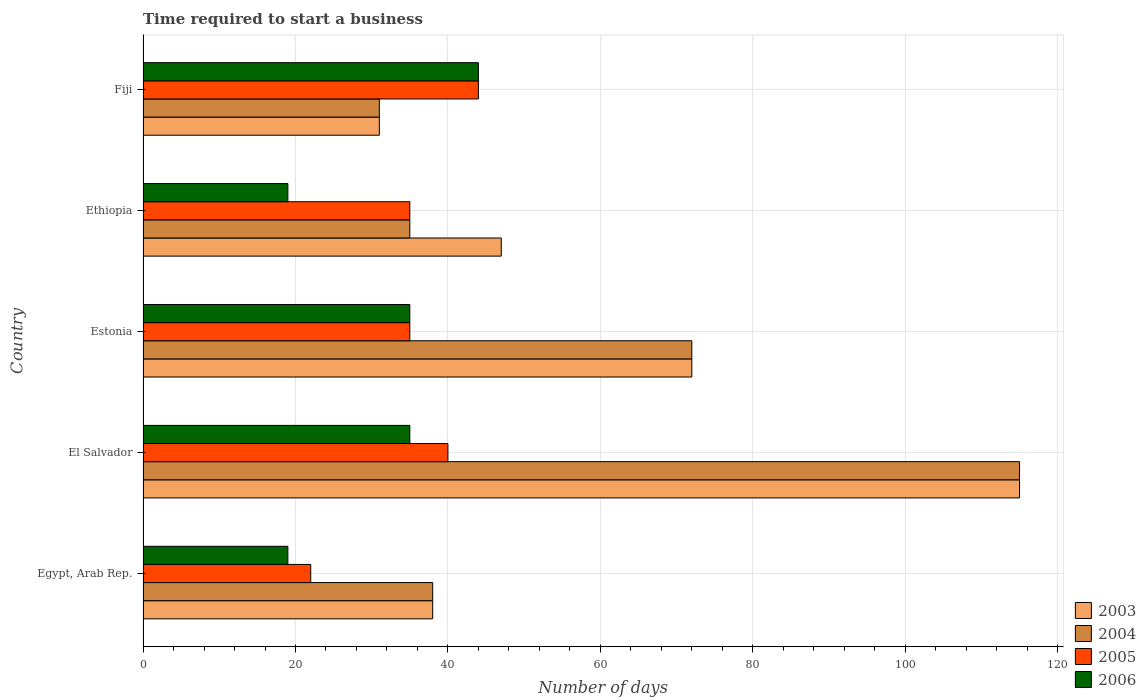How many different coloured bars are there?
Provide a short and direct response. 4. Are the number of bars on each tick of the Y-axis equal?
Your answer should be very brief. Yes. How many bars are there on the 3rd tick from the top?
Give a very brief answer. 4. How many bars are there on the 4th tick from the bottom?
Offer a very short reply. 4. What is the label of the 3rd group of bars from the top?
Your answer should be very brief. Estonia. What is the number of days required to start a business in 2003 in Ethiopia?
Offer a very short reply. 47. Across all countries, what is the maximum number of days required to start a business in 2004?
Offer a very short reply. 115. In which country was the number of days required to start a business in 2006 maximum?
Offer a very short reply. Fiji. In which country was the number of days required to start a business in 2005 minimum?
Your answer should be compact. Egypt, Arab Rep. What is the total number of days required to start a business in 2004 in the graph?
Offer a terse response. 291. What is the difference between the number of days required to start a business in 2003 in El Salvador and that in Estonia?
Give a very brief answer. 43. What is the difference between the number of days required to start a business in 2005 in Fiji and the number of days required to start a business in 2004 in Ethiopia?
Give a very brief answer. 9. What is the average number of days required to start a business in 2005 per country?
Offer a terse response. 35.2. In how many countries, is the number of days required to start a business in 2003 greater than 20 days?
Make the answer very short. 5. What is the ratio of the number of days required to start a business in 2003 in Egypt, Arab Rep. to that in Estonia?
Ensure brevity in your answer.  0.53. Is the difference between the number of days required to start a business in 2003 in El Salvador and Fiji greater than the difference between the number of days required to start a business in 2004 in El Salvador and Fiji?
Offer a terse response. No. What is the difference between the highest and the lowest number of days required to start a business in 2003?
Offer a very short reply. 84. Is it the case that in every country, the sum of the number of days required to start a business in 2005 and number of days required to start a business in 2006 is greater than the number of days required to start a business in 2004?
Provide a short and direct response. No. Are all the bars in the graph horizontal?
Keep it short and to the point. Yes. What is the difference between two consecutive major ticks on the X-axis?
Your response must be concise. 20. Are the values on the major ticks of X-axis written in scientific E-notation?
Ensure brevity in your answer.  No. Where does the legend appear in the graph?
Your answer should be compact. Bottom right. How many legend labels are there?
Give a very brief answer. 4. What is the title of the graph?
Provide a short and direct response. Time required to start a business. Does "1980" appear as one of the legend labels in the graph?
Keep it short and to the point. No. What is the label or title of the X-axis?
Give a very brief answer. Number of days. What is the label or title of the Y-axis?
Give a very brief answer. Country. What is the Number of days of 2003 in Egypt, Arab Rep.?
Provide a succinct answer. 38. What is the Number of days of 2004 in Egypt, Arab Rep.?
Provide a short and direct response. 38. What is the Number of days in 2005 in Egypt, Arab Rep.?
Your answer should be compact. 22. What is the Number of days of 2003 in El Salvador?
Provide a succinct answer. 115. What is the Number of days in 2004 in El Salvador?
Give a very brief answer. 115. What is the Number of days of 2005 in El Salvador?
Your answer should be very brief. 40. What is the Number of days of 2006 in El Salvador?
Your answer should be compact. 35. What is the Number of days of 2004 in Estonia?
Offer a very short reply. 72. What is the Number of days of 2006 in Estonia?
Your response must be concise. 35. What is the Number of days of 2004 in Ethiopia?
Your answer should be compact. 35. What is the Number of days in 2003 in Fiji?
Make the answer very short. 31. Across all countries, what is the maximum Number of days of 2003?
Offer a terse response. 115. Across all countries, what is the maximum Number of days of 2004?
Your answer should be very brief. 115. Across all countries, what is the maximum Number of days in 2005?
Your response must be concise. 44. Across all countries, what is the minimum Number of days of 2003?
Ensure brevity in your answer.  31. Across all countries, what is the minimum Number of days in 2006?
Your answer should be very brief. 19. What is the total Number of days of 2003 in the graph?
Provide a short and direct response. 303. What is the total Number of days in 2004 in the graph?
Provide a short and direct response. 291. What is the total Number of days in 2005 in the graph?
Offer a very short reply. 176. What is the total Number of days of 2006 in the graph?
Your answer should be very brief. 152. What is the difference between the Number of days of 2003 in Egypt, Arab Rep. and that in El Salvador?
Ensure brevity in your answer.  -77. What is the difference between the Number of days in 2004 in Egypt, Arab Rep. and that in El Salvador?
Ensure brevity in your answer.  -77. What is the difference between the Number of days of 2005 in Egypt, Arab Rep. and that in El Salvador?
Keep it short and to the point. -18. What is the difference between the Number of days in 2006 in Egypt, Arab Rep. and that in El Salvador?
Ensure brevity in your answer.  -16. What is the difference between the Number of days of 2003 in Egypt, Arab Rep. and that in Estonia?
Ensure brevity in your answer.  -34. What is the difference between the Number of days of 2004 in Egypt, Arab Rep. and that in Estonia?
Your answer should be compact. -34. What is the difference between the Number of days in 2006 in Egypt, Arab Rep. and that in Estonia?
Provide a succinct answer. -16. What is the difference between the Number of days of 2003 in Egypt, Arab Rep. and that in Ethiopia?
Your answer should be compact. -9. What is the difference between the Number of days in 2004 in Egypt, Arab Rep. and that in Ethiopia?
Offer a terse response. 3. What is the difference between the Number of days in 2005 in Egypt, Arab Rep. and that in Ethiopia?
Keep it short and to the point. -13. What is the difference between the Number of days of 2003 in Egypt, Arab Rep. and that in Fiji?
Your answer should be very brief. 7. What is the difference between the Number of days in 2006 in Egypt, Arab Rep. and that in Fiji?
Keep it short and to the point. -25. What is the difference between the Number of days in 2003 in El Salvador and that in Ethiopia?
Ensure brevity in your answer.  68. What is the difference between the Number of days in 2004 in El Salvador and that in Ethiopia?
Your answer should be compact. 80. What is the difference between the Number of days in 2005 in El Salvador and that in Fiji?
Your response must be concise. -4. What is the difference between the Number of days in 2003 in Estonia and that in Ethiopia?
Keep it short and to the point. 25. What is the difference between the Number of days of 2005 in Estonia and that in Ethiopia?
Your response must be concise. 0. What is the difference between the Number of days of 2005 in Estonia and that in Fiji?
Your answer should be very brief. -9. What is the difference between the Number of days in 2004 in Ethiopia and that in Fiji?
Make the answer very short. 4. What is the difference between the Number of days in 2003 in Egypt, Arab Rep. and the Number of days in 2004 in El Salvador?
Provide a succinct answer. -77. What is the difference between the Number of days of 2003 in Egypt, Arab Rep. and the Number of days of 2006 in El Salvador?
Provide a short and direct response. 3. What is the difference between the Number of days in 2004 in Egypt, Arab Rep. and the Number of days in 2005 in El Salvador?
Offer a very short reply. -2. What is the difference between the Number of days in 2005 in Egypt, Arab Rep. and the Number of days in 2006 in El Salvador?
Your answer should be compact. -13. What is the difference between the Number of days of 2003 in Egypt, Arab Rep. and the Number of days of 2004 in Estonia?
Offer a very short reply. -34. What is the difference between the Number of days in 2003 in Egypt, Arab Rep. and the Number of days in 2006 in Estonia?
Keep it short and to the point. 3. What is the difference between the Number of days in 2003 in Egypt, Arab Rep. and the Number of days in 2005 in Ethiopia?
Make the answer very short. 3. What is the difference between the Number of days in 2005 in Egypt, Arab Rep. and the Number of days in 2006 in Ethiopia?
Provide a succinct answer. 3. What is the difference between the Number of days in 2004 in Egypt, Arab Rep. and the Number of days in 2005 in Fiji?
Provide a succinct answer. -6. What is the difference between the Number of days of 2004 in Egypt, Arab Rep. and the Number of days of 2006 in Fiji?
Give a very brief answer. -6. What is the difference between the Number of days of 2003 in El Salvador and the Number of days of 2004 in Estonia?
Provide a short and direct response. 43. What is the difference between the Number of days of 2003 in El Salvador and the Number of days of 2005 in Estonia?
Your answer should be compact. 80. What is the difference between the Number of days of 2004 in El Salvador and the Number of days of 2005 in Estonia?
Keep it short and to the point. 80. What is the difference between the Number of days of 2003 in El Salvador and the Number of days of 2004 in Ethiopia?
Your answer should be very brief. 80. What is the difference between the Number of days of 2003 in El Salvador and the Number of days of 2006 in Ethiopia?
Keep it short and to the point. 96. What is the difference between the Number of days in 2004 in El Salvador and the Number of days in 2005 in Ethiopia?
Your answer should be compact. 80. What is the difference between the Number of days in 2004 in El Salvador and the Number of days in 2006 in Ethiopia?
Your response must be concise. 96. What is the difference between the Number of days of 2003 in El Salvador and the Number of days of 2006 in Fiji?
Your answer should be very brief. 71. What is the difference between the Number of days of 2004 in El Salvador and the Number of days of 2005 in Fiji?
Provide a succinct answer. 71. What is the difference between the Number of days in 2004 in El Salvador and the Number of days in 2006 in Fiji?
Offer a very short reply. 71. What is the difference between the Number of days in 2005 in El Salvador and the Number of days in 2006 in Fiji?
Ensure brevity in your answer.  -4. What is the difference between the Number of days in 2003 in Estonia and the Number of days in 2004 in Ethiopia?
Make the answer very short. 37. What is the difference between the Number of days of 2003 in Estonia and the Number of days of 2005 in Ethiopia?
Offer a terse response. 37. What is the difference between the Number of days of 2003 in Estonia and the Number of days of 2006 in Ethiopia?
Your answer should be very brief. 53. What is the difference between the Number of days in 2004 in Estonia and the Number of days in 2005 in Ethiopia?
Provide a succinct answer. 37. What is the difference between the Number of days of 2004 in Estonia and the Number of days of 2006 in Ethiopia?
Keep it short and to the point. 53. What is the difference between the Number of days of 2004 in Estonia and the Number of days of 2005 in Fiji?
Make the answer very short. 28. What is the difference between the Number of days in 2004 in Estonia and the Number of days in 2006 in Fiji?
Offer a terse response. 28. What is the difference between the Number of days in 2003 in Ethiopia and the Number of days in 2006 in Fiji?
Offer a terse response. 3. What is the difference between the Number of days in 2004 in Ethiopia and the Number of days in 2005 in Fiji?
Provide a short and direct response. -9. What is the difference between the Number of days in 2004 in Ethiopia and the Number of days in 2006 in Fiji?
Ensure brevity in your answer.  -9. What is the difference between the Number of days in 2005 in Ethiopia and the Number of days in 2006 in Fiji?
Make the answer very short. -9. What is the average Number of days of 2003 per country?
Provide a short and direct response. 60.6. What is the average Number of days of 2004 per country?
Make the answer very short. 58.2. What is the average Number of days of 2005 per country?
Provide a succinct answer. 35.2. What is the average Number of days of 2006 per country?
Your response must be concise. 30.4. What is the difference between the Number of days of 2003 and Number of days of 2004 in Egypt, Arab Rep.?
Your answer should be compact. 0. What is the difference between the Number of days in 2003 and Number of days in 2005 in Egypt, Arab Rep.?
Provide a succinct answer. 16. What is the difference between the Number of days of 2004 and Number of days of 2005 in Egypt, Arab Rep.?
Provide a succinct answer. 16. What is the difference between the Number of days in 2003 and Number of days in 2005 in El Salvador?
Provide a short and direct response. 75. What is the difference between the Number of days of 2003 and Number of days of 2006 in El Salvador?
Your response must be concise. 80. What is the difference between the Number of days in 2004 and Number of days in 2005 in El Salvador?
Your response must be concise. 75. What is the difference between the Number of days of 2005 and Number of days of 2006 in El Salvador?
Offer a very short reply. 5. What is the difference between the Number of days of 2003 and Number of days of 2004 in Estonia?
Provide a short and direct response. 0. What is the difference between the Number of days of 2005 and Number of days of 2006 in Estonia?
Keep it short and to the point. 0. What is the difference between the Number of days of 2003 and Number of days of 2004 in Ethiopia?
Your response must be concise. 12. What is the difference between the Number of days in 2003 and Number of days in 2005 in Ethiopia?
Your answer should be very brief. 12. What is the difference between the Number of days in 2004 and Number of days in 2005 in Ethiopia?
Your answer should be compact. 0. What is the difference between the Number of days of 2004 and Number of days of 2006 in Ethiopia?
Your answer should be compact. 16. What is the difference between the Number of days in 2005 and Number of days in 2006 in Ethiopia?
Your answer should be compact. 16. What is the difference between the Number of days in 2004 and Number of days in 2006 in Fiji?
Keep it short and to the point. -13. What is the difference between the Number of days in 2005 and Number of days in 2006 in Fiji?
Ensure brevity in your answer.  0. What is the ratio of the Number of days in 2003 in Egypt, Arab Rep. to that in El Salvador?
Provide a succinct answer. 0.33. What is the ratio of the Number of days in 2004 in Egypt, Arab Rep. to that in El Salvador?
Provide a short and direct response. 0.33. What is the ratio of the Number of days in 2005 in Egypt, Arab Rep. to that in El Salvador?
Provide a succinct answer. 0.55. What is the ratio of the Number of days in 2006 in Egypt, Arab Rep. to that in El Salvador?
Your response must be concise. 0.54. What is the ratio of the Number of days in 2003 in Egypt, Arab Rep. to that in Estonia?
Offer a very short reply. 0.53. What is the ratio of the Number of days of 2004 in Egypt, Arab Rep. to that in Estonia?
Your answer should be compact. 0.53. What is the ratio of the Number of days of 2005 in Egypt, Arab Rep. to that in Estonia?
Your answer should be very brief. 0.63. What is the ratio of the Number of days in 2006 in Egypt, Arab Rep. to that in Estonia?
Keep it short and to the point. 0.54. What is the ratio of the Number of days of 2003 in Egypt, Arab Rep. to that in Ethiopia?
Make the answer very short. 0.81. What is the ratio of the Number of days of 2004 in Egypt, Arab Rep. to that in Ethiopia?
Keep it short and to the point. 1.09. What is the ratio of the Number of days in 2005 in Egypt, Arab Rep. to that in Ethiopia?
Give a very brief answer. 0.63. What is the ratio of the Number of days in 2006 in Egypt, Arab Rep. to that in Ethiopia?
Your response must be concise. 1. What is the ratio of the Number of days in 2003 in Egypt, Arab Rep. to that in Fiji?
Keep it short and to the point. 1.23. What is the ratio of the Number of days in 2004 in Egypt, Arab Rep. to that in Fiji?
Keep it short and to the point. 1.23. What is the ratio of the Number of days in 2005 in Egypt, Arab Rep. to that in Fiji?
Your response must be concise. 0.5. What is the ratio of the Number of days of 2006 in Egypt, Arab Rep. to that in Fiji?
Ensure brevity in your answer.  0.43. What is the ratio of the Number of days in 2003 in El Salvador to that in Estonia?
Ensure brevity in your answer.  1.6. What is the ratio of the Number of days of 2004 in El Salvador to that in Estonia?
Offer a terse response. 1.6. What is the ratio of the Number of days in 2006 in El Salvador to that in Estonia?
Make the answer very short. 1. What is the ratio of the Number of days in 2003 in El Salvador to that in Ethiopia?
Keep it short and to the point. 2.45. What is the ratio of the Number of days of 2004 in El Salvador to that in Ethiopia?
Offer a terse response. 3.29. What is the ratio of the Number of days of 2005 in El Salvador to that in Ethiopia?
Provide a short and direct response. 1.14. What is the ratio of the Number of days in 2006 in El Salvador to that in Ethiopia?
Ensure brevity in your answer.  1.84. What is the ratio of the Number of days of 2003 in El Salvador to that in Fiji?
Offer a very short reply. 3.71. What is the ratio of the Number of days of 2004 in El Salvador to that in Fiji?
Offer a terse response. 3.71. What is the ratio of the Number of days of 2006 in El Salvador to that in Fiji?
Keep it short and to the point. 0.8. What is the ratio of the Number of days of 2003 in Estonia to that in Ethiopia?
Your answer should be very brief. 1.53. What is the ratio of the Number of days of 2004 in Estonia to that in Ethiopia?
Keep it short and to the point. 2.06. What is the ratio of the Number of days of 2006 in Estonia to that in Ethiopia?
Give a very brief answer. 1.84. What is the ratio of the Number of days of 2003 in Estonia to that in Fiji?
Your answer should be very brief. 2.32. What is the ratio of the Number of days of 2004 in Estonia to that in Fiji?
Give a very brief answer. 2.32. What is the ratio of the Number of days in 2005 in Estonia to that in Fiji?
Ensure brevity in your answer.  0.8. What is the ratio of the Number of days of 2006 in Estonia to that in Fiji?
Offer a terse response. 0.8. What is the ratio of the Number of days of 2003 in Ethiopia to that in Fiji?
Your answer should be compact. 1.52. What is the ratio of the Number of days in 2004 in Ethiopia to that in Fiji?
Your answer should be compact. 1.13. What is the ratio of the Number of days in 2005 in Ethiopia to that in Fiji?
Make the answer very short. 0.8. What is the ratio of the Number of days in 2006 in Ethiopia to that in Fiji?
Provide a short and direct response. 0.43. What is the difference between the highest and the second highest Number of days of 2003?
Provide a short and direct response. 43. What is the difference between the highest and the lowest Number of days of 2003?
Provide a succinct answer. 84. What is the difference between the highest and the lowest Number of days in 2004?
Keep it short and to the point. 84. What is the difference between the highest and the lowest Number of days of 2006?
Provide a short and direct response. 25. 